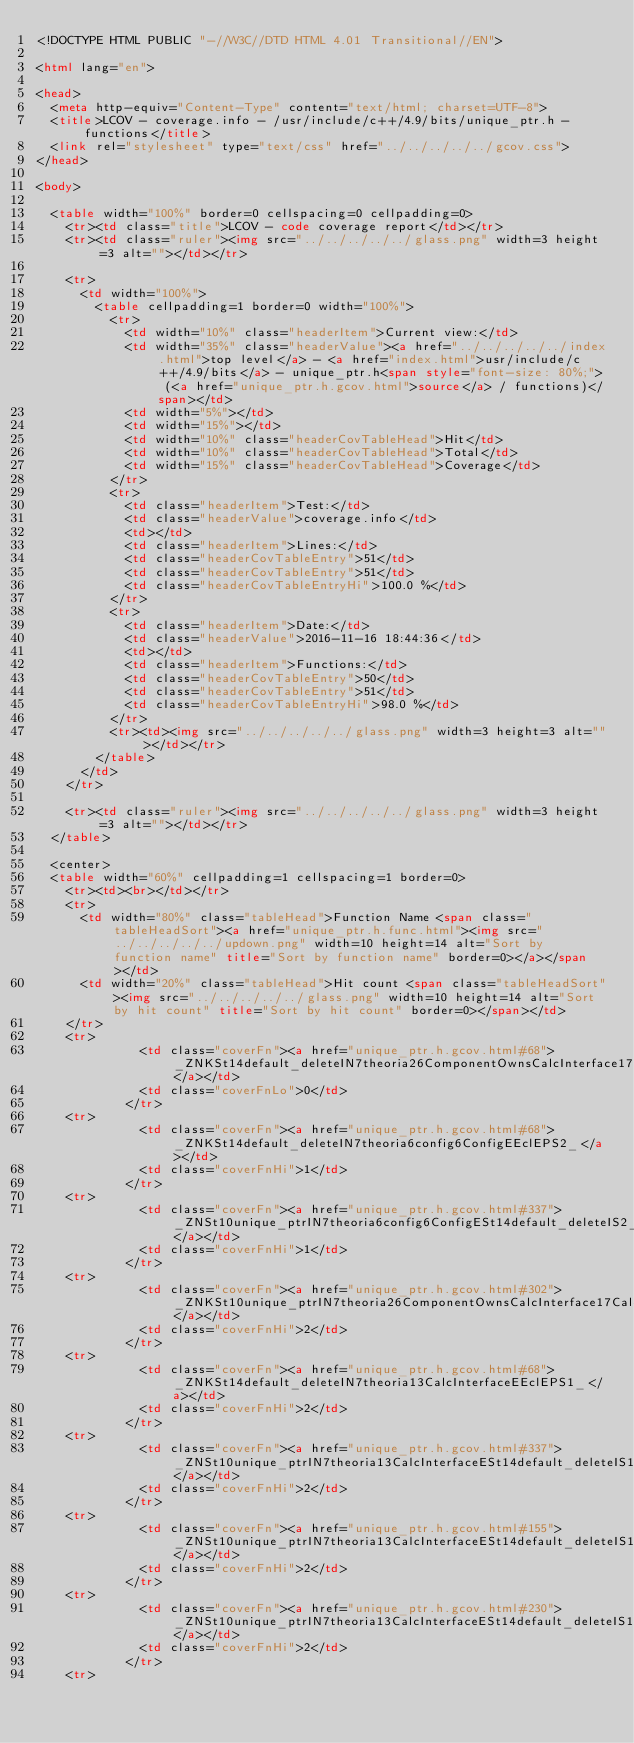<code> <loc_0><loc_0><loc_500><loc_500><_HTML_><!DOCTYPE HTML PUBLIC "-//W3C//DTD HTML 4.01 Transitional//EN">

<html lang="en">

<head>
  <meta http-equiv="Content-Type" content="text/html; charset=UTF-8">
  <title>LCOV - coverage.info - /usr/include/c++/4.9/bits/unique_ptr.h - functions</title>
  <link rel="stylesheet" type="text/css" href="../../../../../gcov.css">
</head>

<body>

  <table width="100%" border=0 cellspacing=0 cellpadding=0>
    <tr><td class="title">LCOV - code coverage report</td></tr>
    <tr><td class="ruler"><img src="../../../../../glass.png" width=3 height=3 alt=""></td></tr>

    <tr>
      <td width="100%">
        <table cellpadding=1 border=0 width="100%">
          <tr>
            <td width="10%" class="headerItem">Current view:</td>
            <td width="35%" class="headerValue"><a href="../../../../../index.html">top level</a> - <a href="index.html">usr/include/c++/4.9/bits</a> - unique_ptr.h<span style="font-size: 80%;"> (<a href="unique_ptr.h.gcov.html">source</a> / functions)</span></td>
            <td width="5%"></td>
            <td width="15%"></td>
            <td width="10%" class="headerCovTableHead">Hit</td>
            <td width="10%" class="headerCovTableHead">Total</td>
            <td width="15%" class="headerCovTableHead">Coverage</td>
          </tr>
          <tr>
            <td class="headerItem">Test:</td>
            <td class="headerValue">coverage.info</td>
            <td></td>
            <td class="headerItem">Lines:</td>
            <td class="headerCovTableEntry">51</td>
            <td class="headerCovTableEntry">51</td>
            <td class="headerCovTableEntryHi">100.0 %</td>
          </tr>
          <tr>
            <td class="headerItem">Date:</td>
            <td class="headerValue">2016-11-16 18:44:36</td>
            <td></td>
            <td class="headerItem">Functions:</td>
            <td class="headerCovTableEntry">50</td>
            <td class="headerCovTableEntry">51</td>
            <td class="headerCovTableEntryHi">98.0 %</td>
          </tr>
          <tr><td><img src="../../../../../glass.png" width=3 height=3 alt=""></td></tr>
        </table>
      </td>
    </tr>

    <tr><td class="ruler"><img src="../../../../../glass.png" width=3 height=3 alt=""></td></tr>
  </table>

  <center>
  <table width="60%" cellpadding=1 cellspacing=1 border=0>
    <tr><td><br></td></tr>
    <tr>
      <td width="80%" class="tableHead">Function Name <span class="tableHeadSort"><a href="unique_ptr.h.func.html"><img src="../../../../../updown.png" width=10 height=14 alt="Sort by function name" title="Sort by function name" border=0></a></span></td>
      <td width="20%" class="tableHead">Hit count <span class="tableHeadSort"><img src="../../../../../glass.png" width=10 height=14 alt="Sort by hit count" title="Sort by hit count" border=0></span></td>
    </tr>
    <tr>
              <td class="coverFn"><a href="unique_ptr.h.gcov.html#68">_ZNKSt14default_deleteIN7theoria26ComponentOwnsCalcInterface17CalcInterfaceImplEEclEPS2_</a></td>
              <td class="coverFnLo">0</td>
            </tr>
    <tr>
              <td class="coverFn"><a href="unique_ptr.h.gcov.html#68">_ZNKSt14default_deleteIN7theoria6config6ConfigEEclEPS2_</a></td>
              <td class="coverFnHi">1</td>
            </tr>
    <tr>
              <td class="coverFn"><a href="unique_ptr.h.gcov.html#337">_ZNSt10unique_ptrIN7theoria6config6ConfigESt14default_deleteIS2_EE5resetEPS2_</a></td>
              <td class="coverFnHi">1</td>
            </tr>
    <tr>
              <td class="coverFn"><a href="unique_ptr.h.gcov.html#302">_ZNKSt10unique_ptrIN7theoria26ComponentOwnsCalcInterface17CalcInterfaceImplESt14default_deleteIS2_EE3getEv</a></td>
              <td class="coverFnHi">2</td>
            </tr>
    <tr>
              <td class="coverFn"><a href="unique_ptr.h.gcov.html#68">_ZNKSt14default_deleteIN7theoria13CalcInterfaceEEclEPS1_</a></td>
              <td class="coverFnHi">2</td>
            </tr>
    <tr>
              <td class="coverFn"><a href="unique_ptr.h.gcov.html#337">_ZNSt10unique_ptrIN7theoria13CalcInterfaceESt14default_deleteIS1_EE5resetEPS1_</a></td>
              <td class="coverFnHi">2</td>
            </tr>
    <tr>
              <td class="coverFn"><a href="unique_ptr.h.gcov.html#155">_ZNSt10unique_ptrIN7theoria13CalcInterfaceESt14default_deleteIS1_EEC1Ev</a></td>
              <td class="coverFnHi">2</td>
            </tr>
    <tr>
              <td class="coverFn"><a href="unique_ptr.h.gcov.html#230">_ZNSt10unique_ptrIN7theoria13CalcInterfaceESt14default_deleteIS1_EED2Ev</a></td>
              <td class="coverFnHi">2</td>
            </tr>
    <tr></code> 